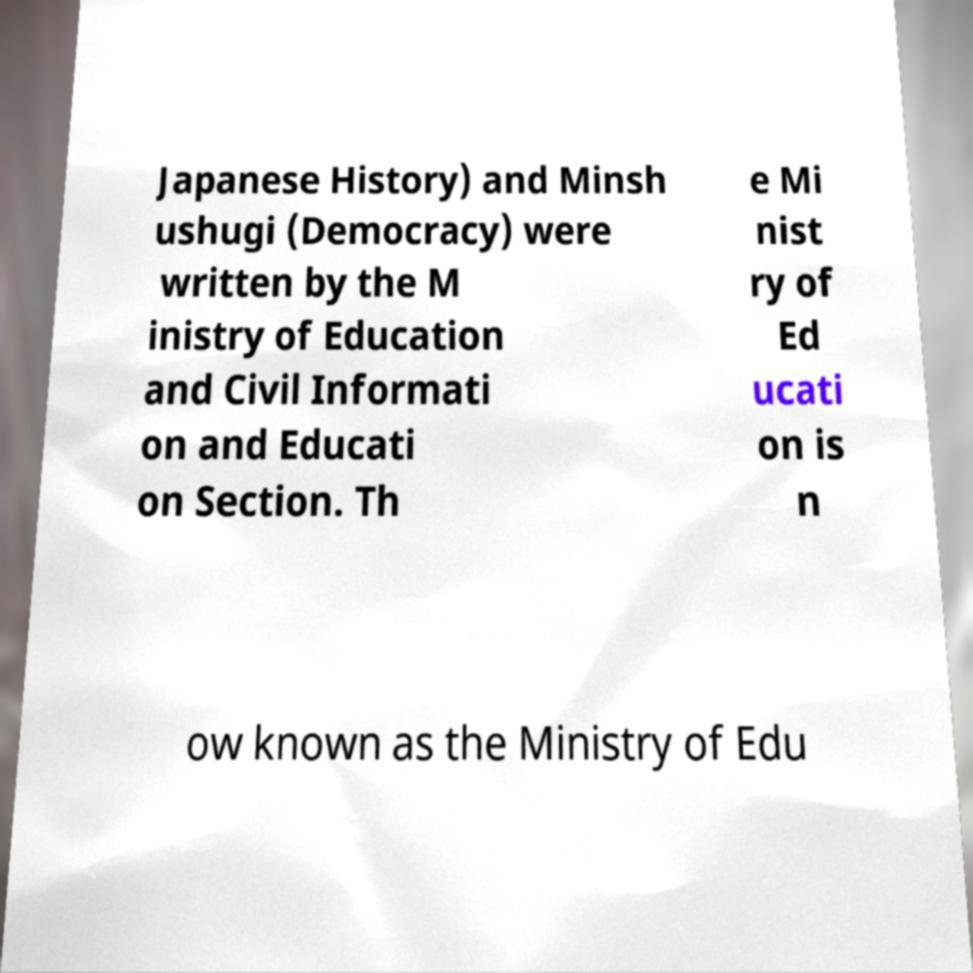Please read and relay the text visible in this image. What does it say? Japanese History) and Minsh ushugi (Democracy) were written by the M inistry of Education and Civil Informati on and Educati on Section. Th e Mi nist ry of Ed ucati on is n ow known as the Ministry of Edu 